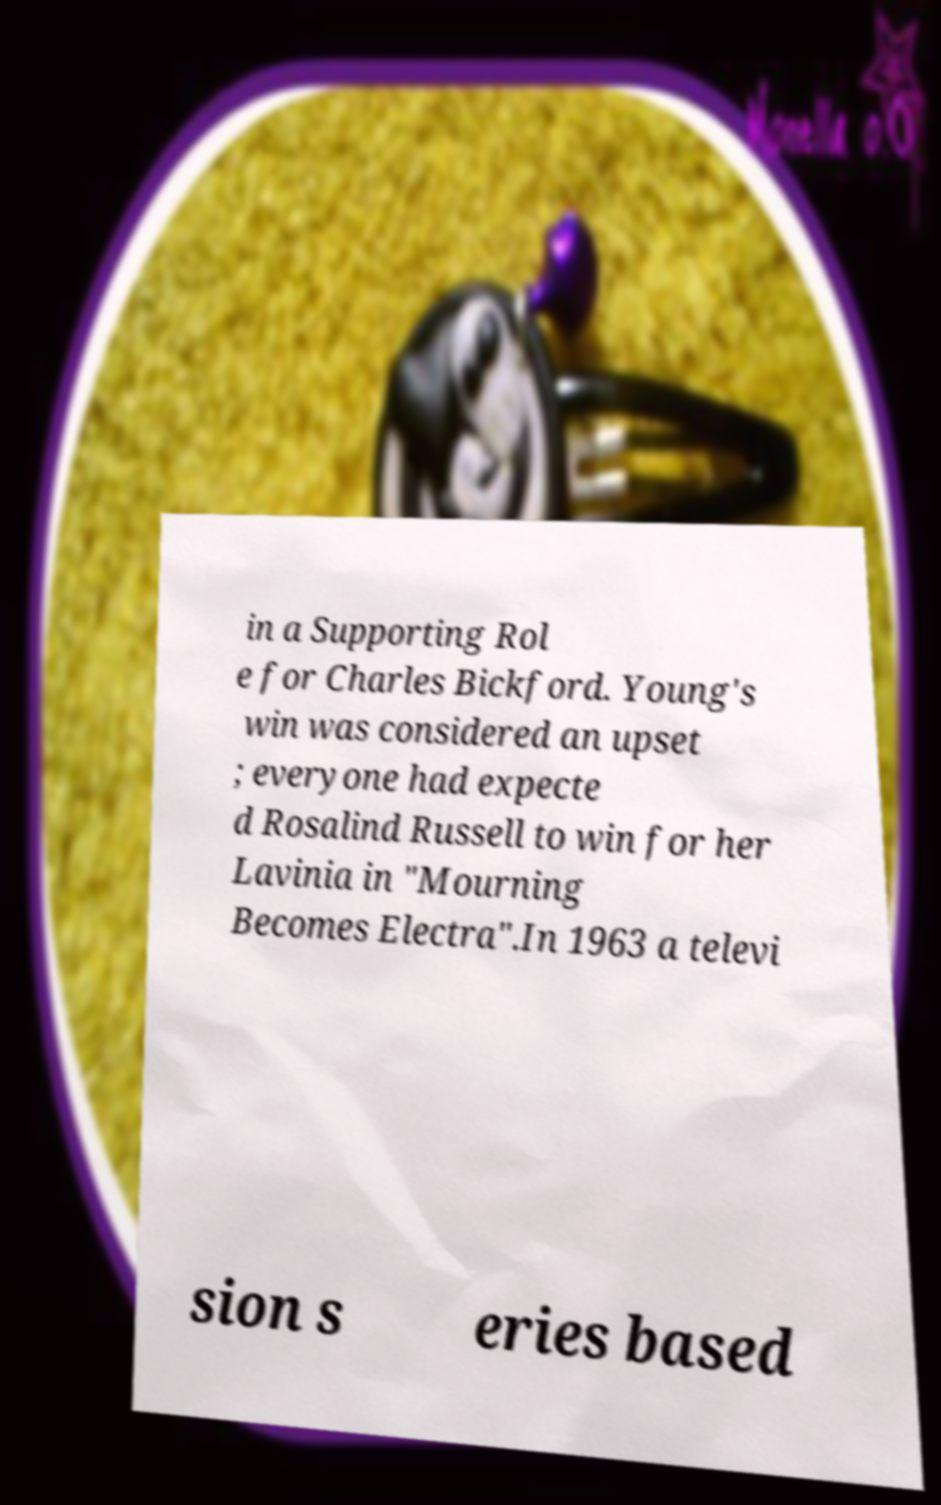Could you assist in decoding the text presented in this image and type it out clearly? in a Supporting Rol e for Charles Bickford. Young's win was considered an upset ; everyone had expecte d Rosalind Russell to win for her Lavinia in "Mourning Becomes Electra".In 1963 a televi sion s eries based 